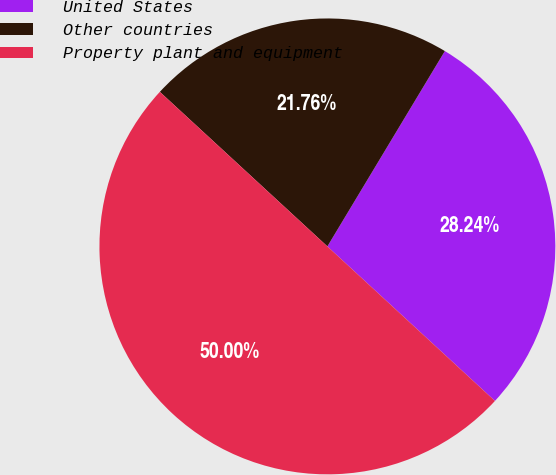Convert chart to OTSL. <chart><loc_0><loc_0><loc_500><loc_500><pie_chart><fcel>United States<fcel>Other countries<fcel>Property plant and equipment<nl><fcel>28.24%<fcel>21.76%<fcel>50.0%<nl></chart> 